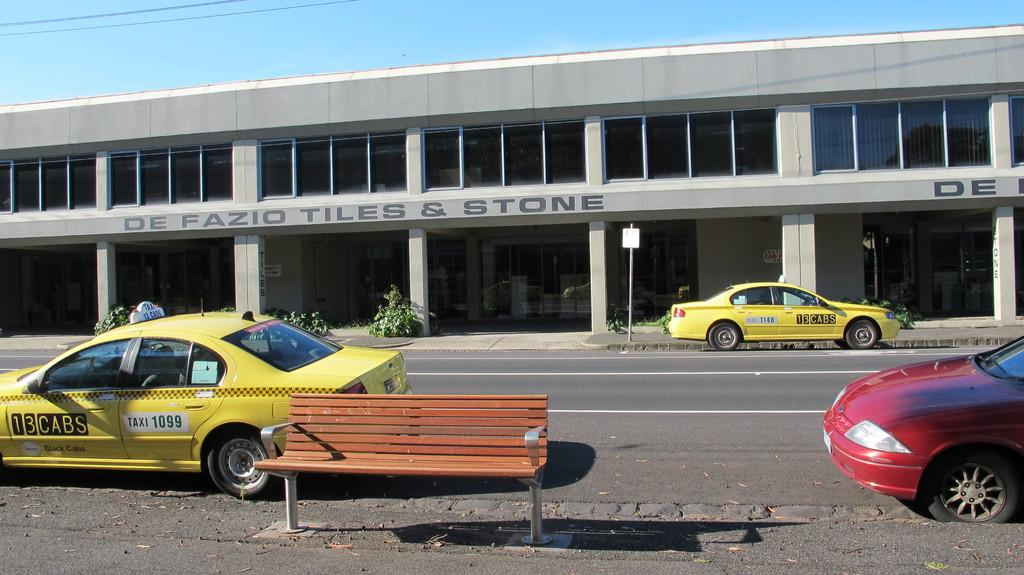<image>
Write a terse but informative summary of the picture. a building that has a tiles & stone title on it 